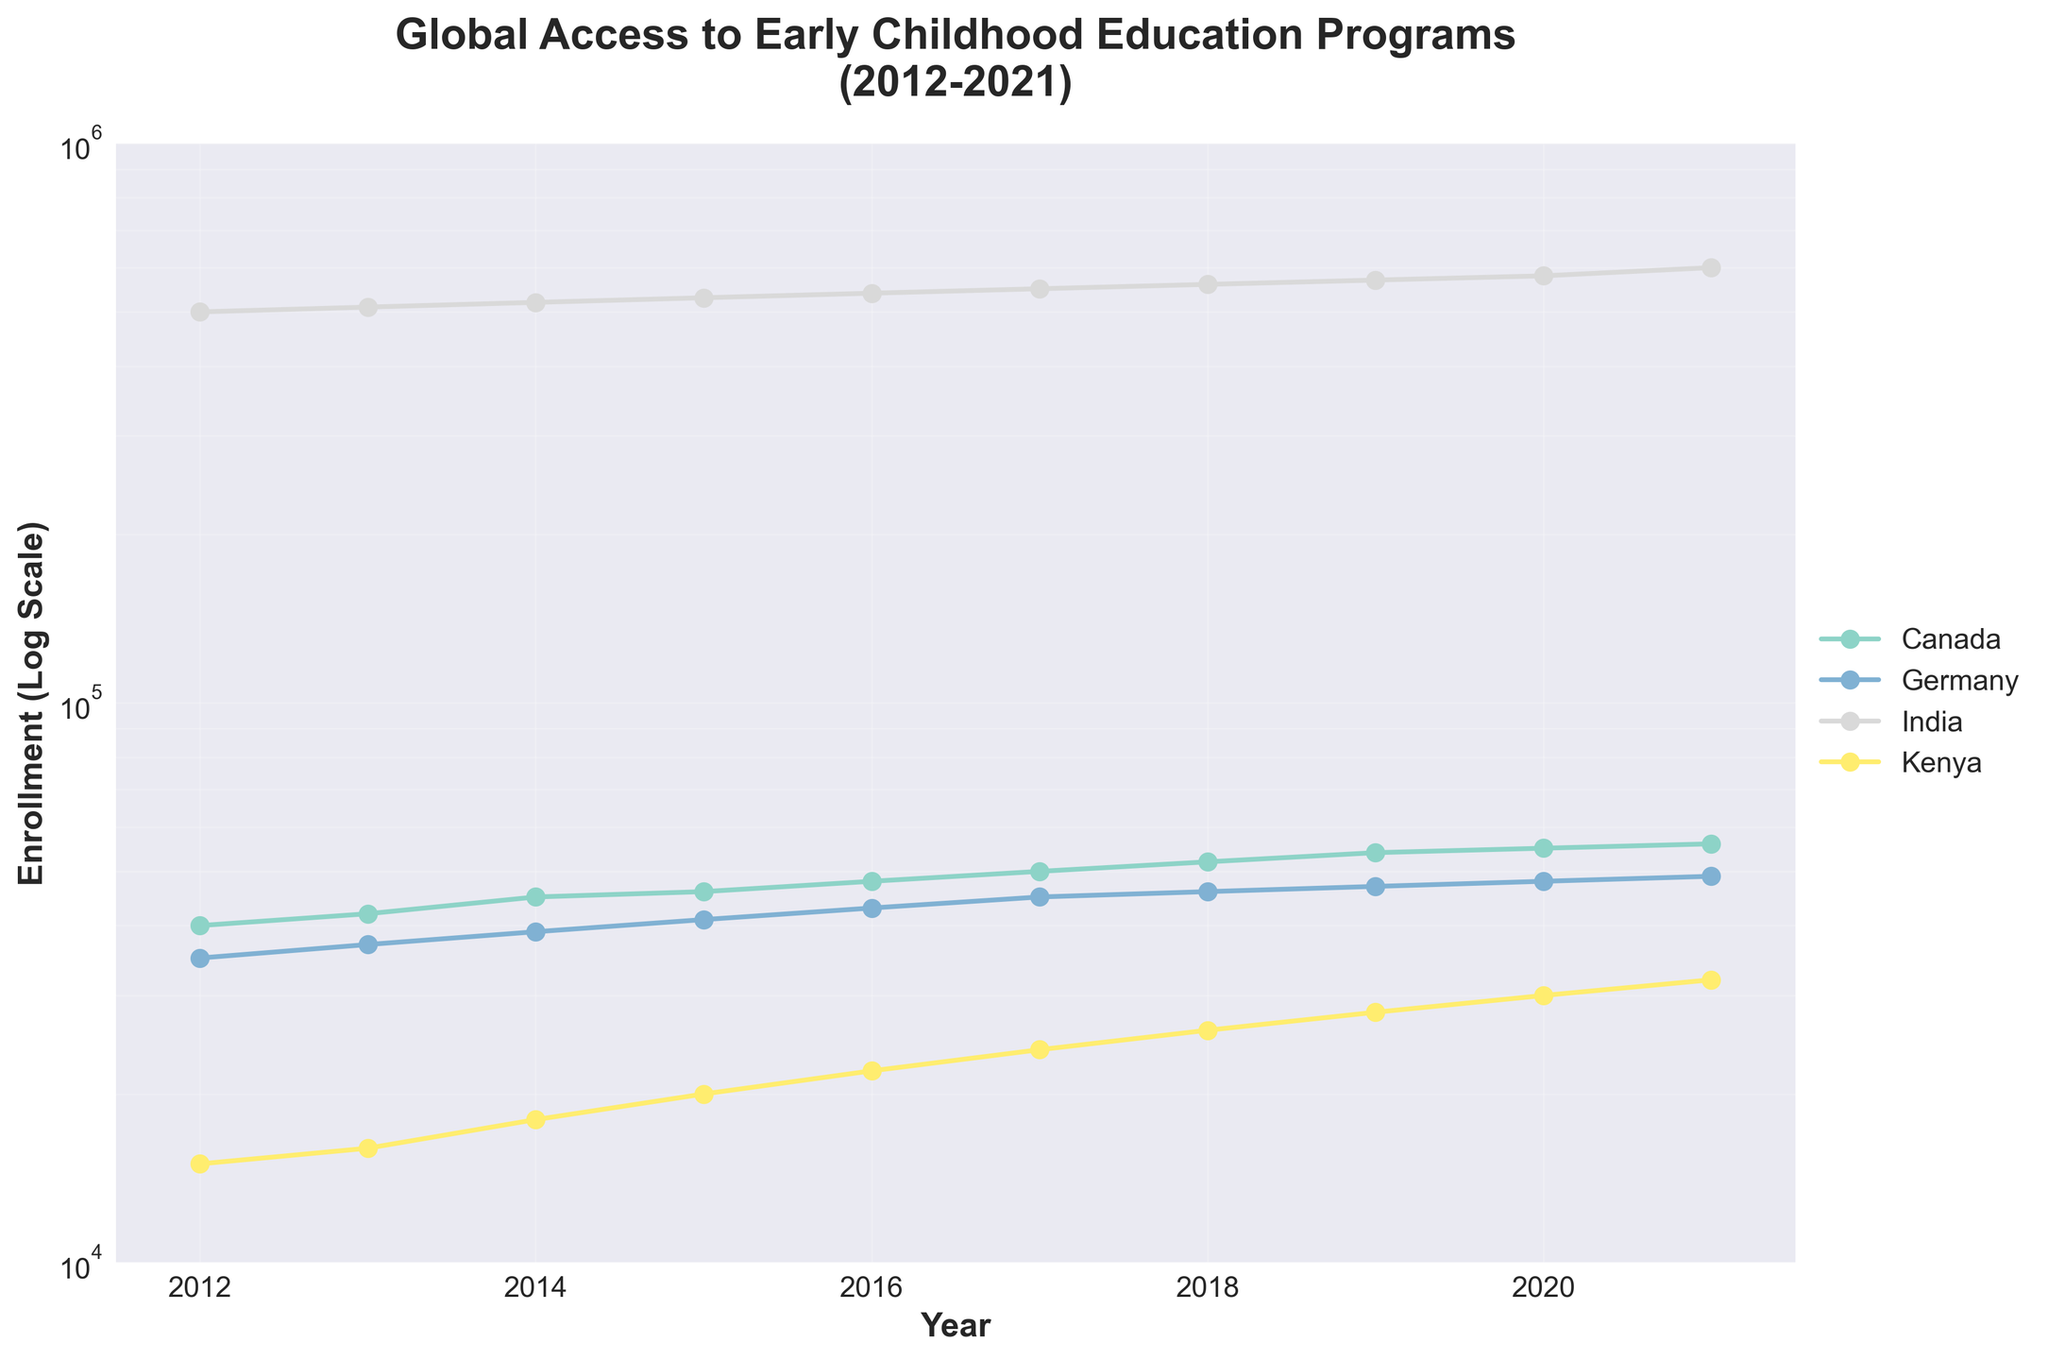Which country had the highest enrollment in 2021? To find the highest enrollment in 2021, compare the final data points of each country. India, with 600,000, has the highest enrollment.
Answer: India What general trend in enrollment does Canada exhibit from 2012 to 2021? Observing the data points for Canada over the years from 2012 to 2021, the enrollment consistently increases every year.
Answer: Increasing trend What is the approximate difference in enrollment between Germany and Kenya in 2017? Look at the data points for Germany and Kenya in 2017. Germany has approximately 45,000 enrollments, and Kenya has around 24,000 enrollments. The difference is 45,000 - 24,000 = 21,000.
Answer: 21,000 In which year did India reach 550,000 enrollments? Trace the line for India, finding the point where it reaches 550,000 enrollments. This occurs in 2017.
Answer: 2017 What year shows a crossing point between Canada's and Germany's enrollment lines? By comparing the overlapping of lines for Canada and Germany, there is no crossing point as Canada's line always stays above Germany’s.
Answer: None Which country has shown a steep increase in enrollment from 2012 to 2021? The country showing the steepest increase in enrollment is India, as it has the most significant change in values on the log scale plot from 500,000 in 2012 to 600,000 in 2021.
Answer: India What is the overall enrollment trend for Kenya from 2012 to 2021 on the log scale? Observing the log scale, Kenya’s enrollment trend shows a notable increase every year from 15,000 in 2012 to 32,000 in 2021.
Answer: Increasing trend How do the maximum and minimum enrollments of countries in this dataset compare? Assess the highest enrollment (India with 600,000 in 2021) and the lowest enrollment (Kenya with 15,000 in 2012). The range is from 15,000 to 600,000.
Answer: 15,000 to 600,000 Which country had a smaller increase in enrollment from 2012 to 2021, Germany or Canada? Calculate the difference for both countries between 2012 and 2021: Germany (49,000 - 35,000 = 14,000) and Canada (56,000 - 40,000 = 16,000). Germany had a smaller increase.
Answer: Germany What is the log scale difference between the enrollments of India and Canada in 2021? On the log scale, India's 2021 enrollment of 600,000 compared to Canada’s 56,000 shows their ratio on the log scale. The difference is about log_10(600,000) - log_10(56,000). Calculate: log_10(600,000) = 5.78, log_10(56,000) ≈ 4.75. The difference is roughly 5.78 - 4.75 = 1.03.
Answer: 1.03 